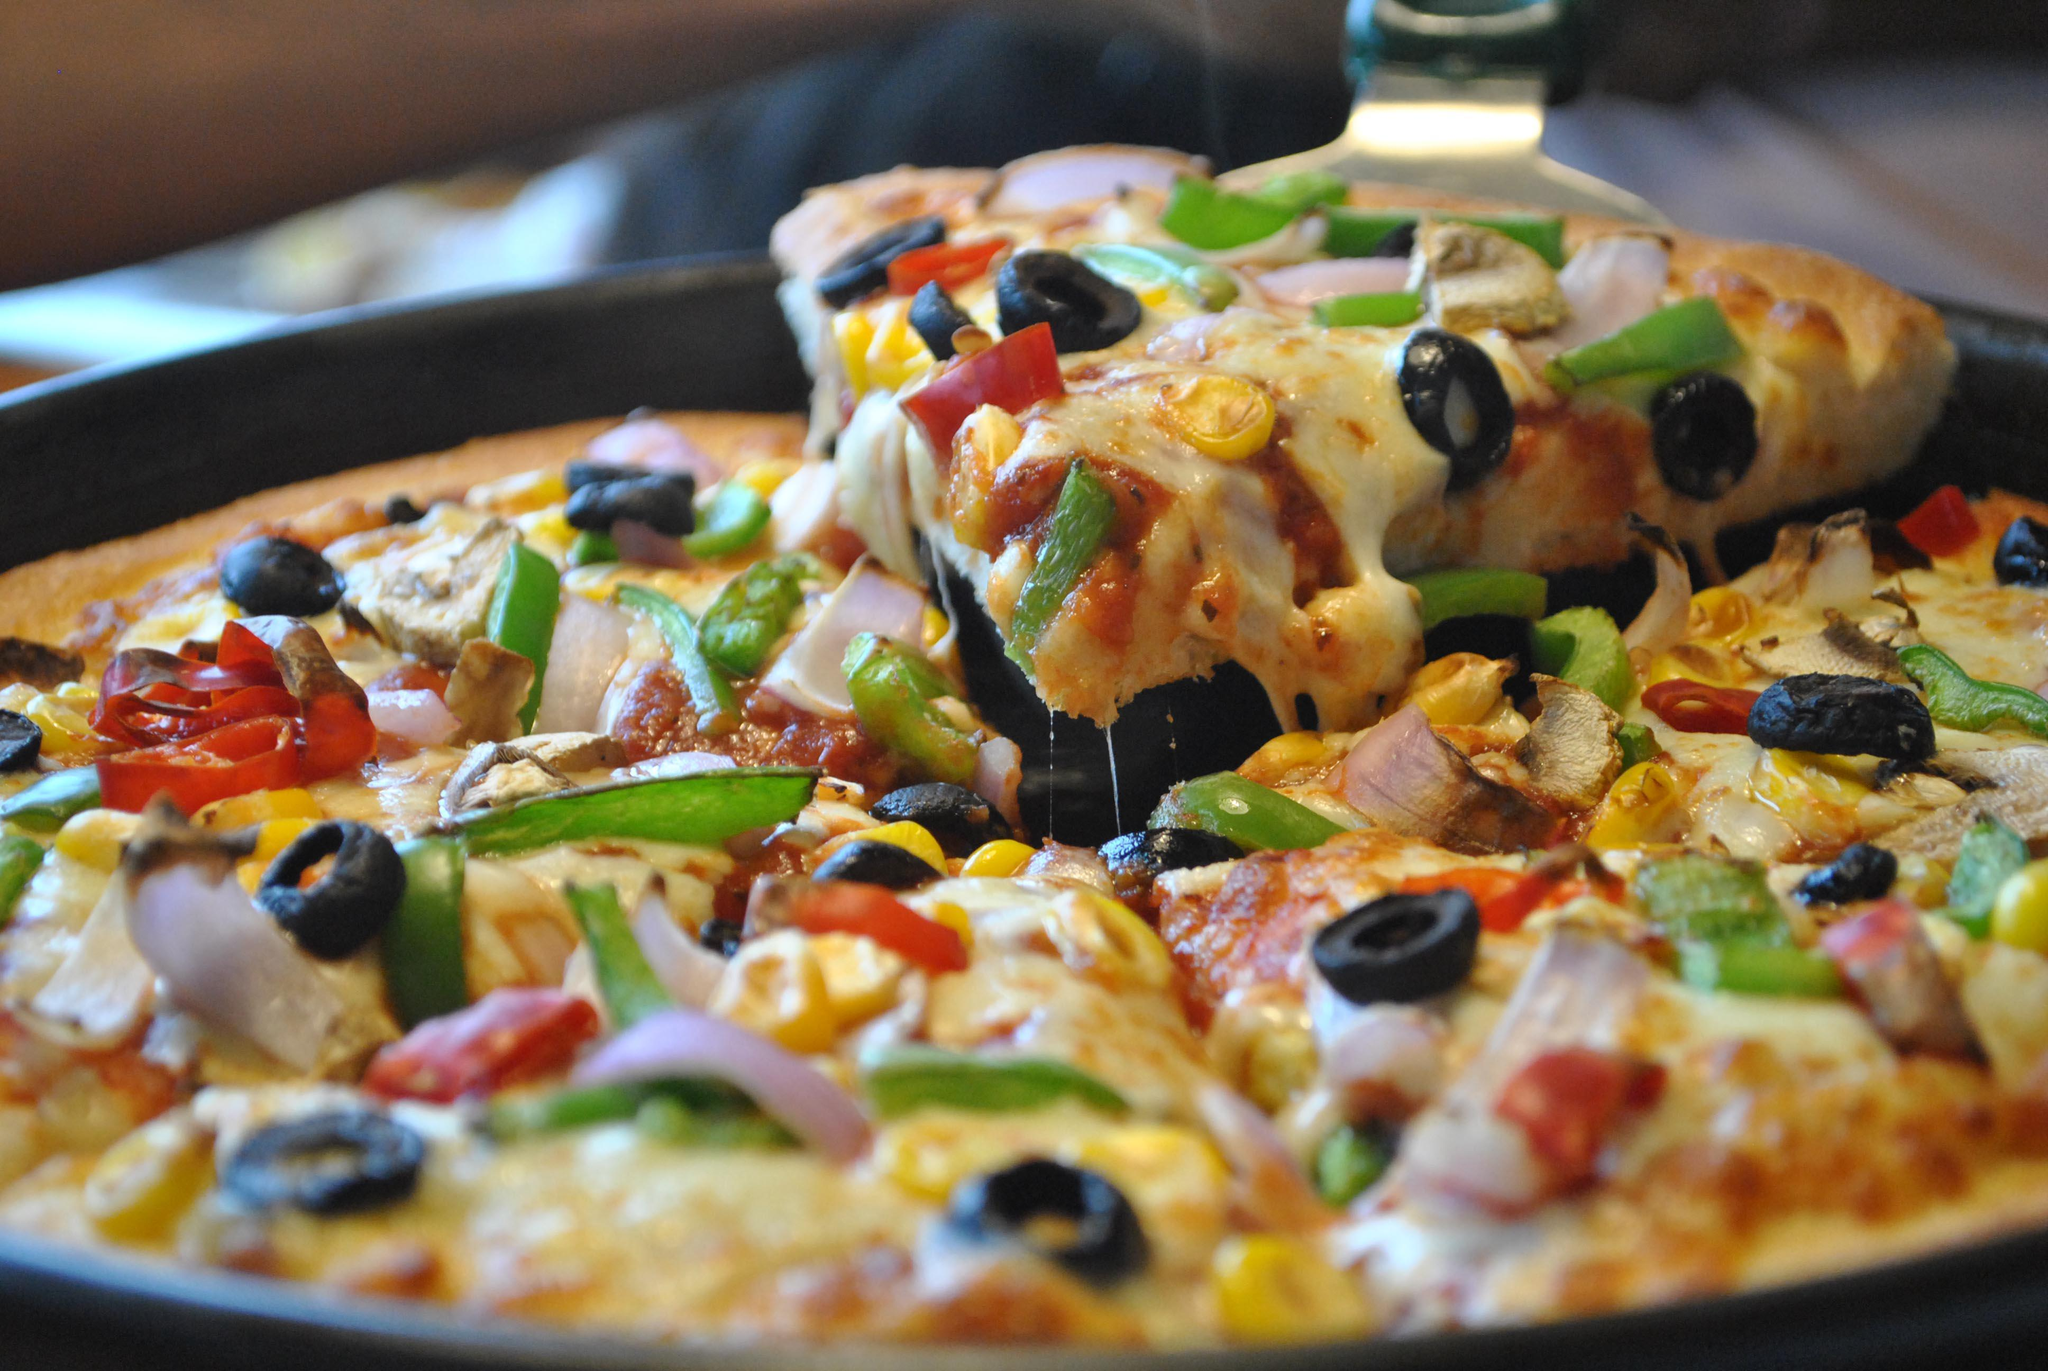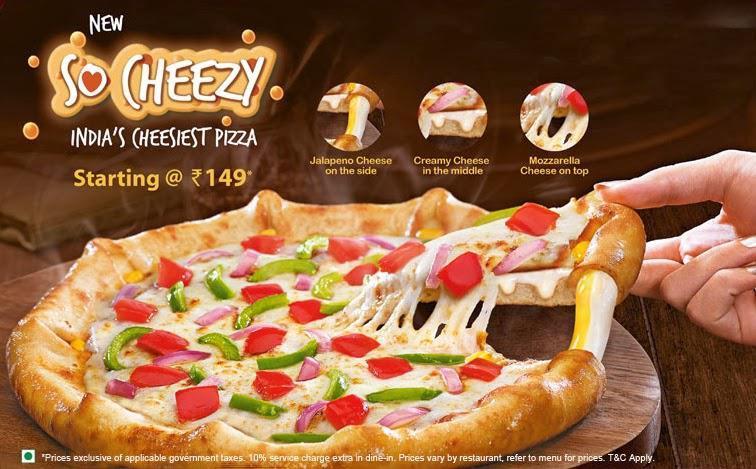The first image is the image on the left, the second image is the image on the right. Assess this claim about the two images: "There are exactly two pizzas.". Correct or not? Answer yes or no. Yes. The first image is the image on the left, the second image is the image on the right. Assess this claim about the two images: "There are no more than 2 pizzas.". Correct or not? Answer yes or no. Yes. 